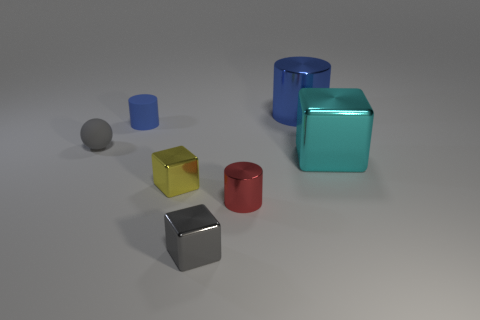What number of red objects have the same material as the tiny red cylinder?
Keep it short and to the point. 0. How many metal objects are big gray cylinders or big objects?
Make the answer very short. 2. What material is the blue cylinder that is the same size as the cyan cube?
Offer a terse response. Metal. Is there another thing made of the same material as the tiny red object?
Your answer should be very brief. Yes. There is a blue object that is in front of the blue thing on the right side of the gray object that is to the right of the small yellow metal block; what shape is it?
Offer a terse response. Cylinder. Does the red object have the same size as the blue thing that is in front of the big blue thing?
Ensure brevity in your answer.  Yes. What shape is the thing that is behind the small gray matte thing and left of the big metal cylinder?
Your answer should be very brief. Cylinder. What number of small things are gray rubber objects or brown cylinders?
Keep it short and to the point. 1. Are there an equal number of things that are behind the cyan cube and metallic objects behind the yellow shiny block?
Provide a succinct answer. No. What number of other objects are the same color as the big block?
Keep it short and to the point. 0. 